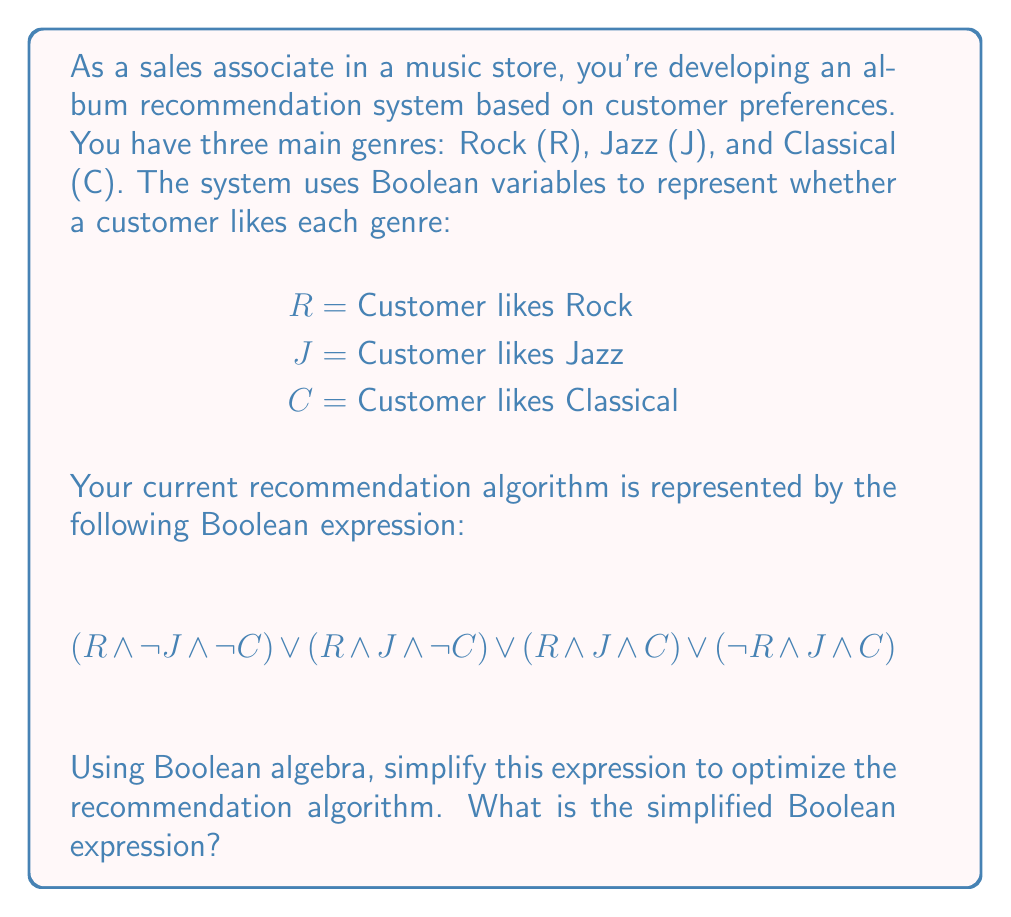Help me with this question. Let's simplify the expression step by step using Boolean algebra laws:

1) First, let's identify common terms:
   $$(R \land \neg J \land \neg C) \lor (R \land J \land \neg C) \lor (R \land J \land C) \lor (\neg R \land J \land C)$$

2) We can factor out $R$ from the first three terms:
   $$R(\neg J \land \neg C) \lor R(J \land \neg C) \lor R(J \land C) \lor (\neg R \land J \land C)$$

3) Now, we can apply the distributive law to the $R$ terms:
   $$R(\neg J \land \neg C) \lor R(J \land \neg C \lor J \land C) \lor (\neg R \land J \land C)$$

4) Simplify $J \land \neg C \lor J \land C$ using the distributive law:
   $$R(\neg J \land \neg C) \lor R(J \land (\neg C \lor C)) \lor (\neg R \land J \land C)$$

5) $\neg C \lor C$ is always true (law of excluded middle), so we can simplify:
   $$R(\neg J \land \neg C) \lor R(J) \lor (\neg R \land J \land C)$$

6) Distribute $R$ again:
   $$R \land \neg J \land \neg C \lor R \land J \lor \neg R \land J \land C$$

7) The term $R \land J$ absorbs $R \land J \land C$, so we can remove the last term:
   $$R \land \neg J \land \neg C \lor R \land J$$

8) Finally, we can factor out $R$:
   $$R \land (\neg J \land \neg C \lor J)$$

This is our simplified Boolean expression.
Answer: $R \land (\neg J \land \neg C \lor J)$ 